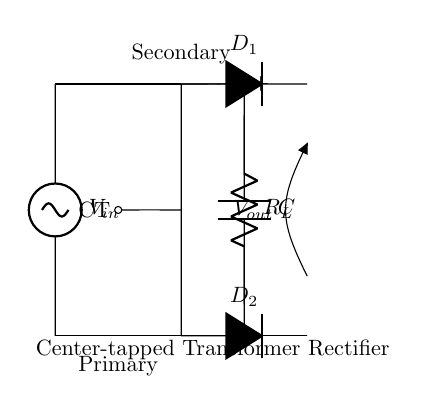what is the type of transformer used in this circuit? The diagram shows a center-tapped transformer, indicated by the center tap (CT) connection that splits the secondary coil into two equal halves for rectification.
Answer: center-tapped transformer how many diodes are present in this rectifier circuit? The circuit depicts two diodes, marked as D1 and D2, connected to each end of the center-tapped transformer.
Answer: two what is the function of the capacitor in this circuit? The capacitor (C) smoothens the output voltage by filtering out the ripples produced during the rectification process, effectively stabilizing the DC output.
Answer: smoothing what is the output voltage type of this rectifier? The output voltage derived from this circuit is a pulsating direct current (DC), which results from the rectification of the AC voltage provided by the transformer.
Answer: pulsating DC how does the center tap impact the rectification process? The center tap allows each diode (D1 and D2) to conduct during opposite halves of the AC cycle, effectively doubling the output voltage while providing a return path that stabilizes the output current.
Answer: doubles voltage what is the load resistor labeled in the circuit? The load resistor is denoted as R_L, and it is located in the circuit below the diodes, representing the resistance that the rectified voltage will drive.
Answer: R_L what is the voltage input to this circuit? The input voltage is indicated as V_in, which supplies the alternating current to the primary side of the transformer for step-up or step-down before rectification.
Answer: V_in 